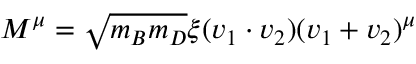Convert formula to latex. <formula><loc_0><loc_0><loc_500><loc_500>M ^ { \mu } = \sqrt { m _ { B } m _ { D } } \xi ( v _ { 1 } \cdot v _ { 2 } ) ( v _ { 1 } + v _ { 2 } ) ^ { \mu }</formula> 